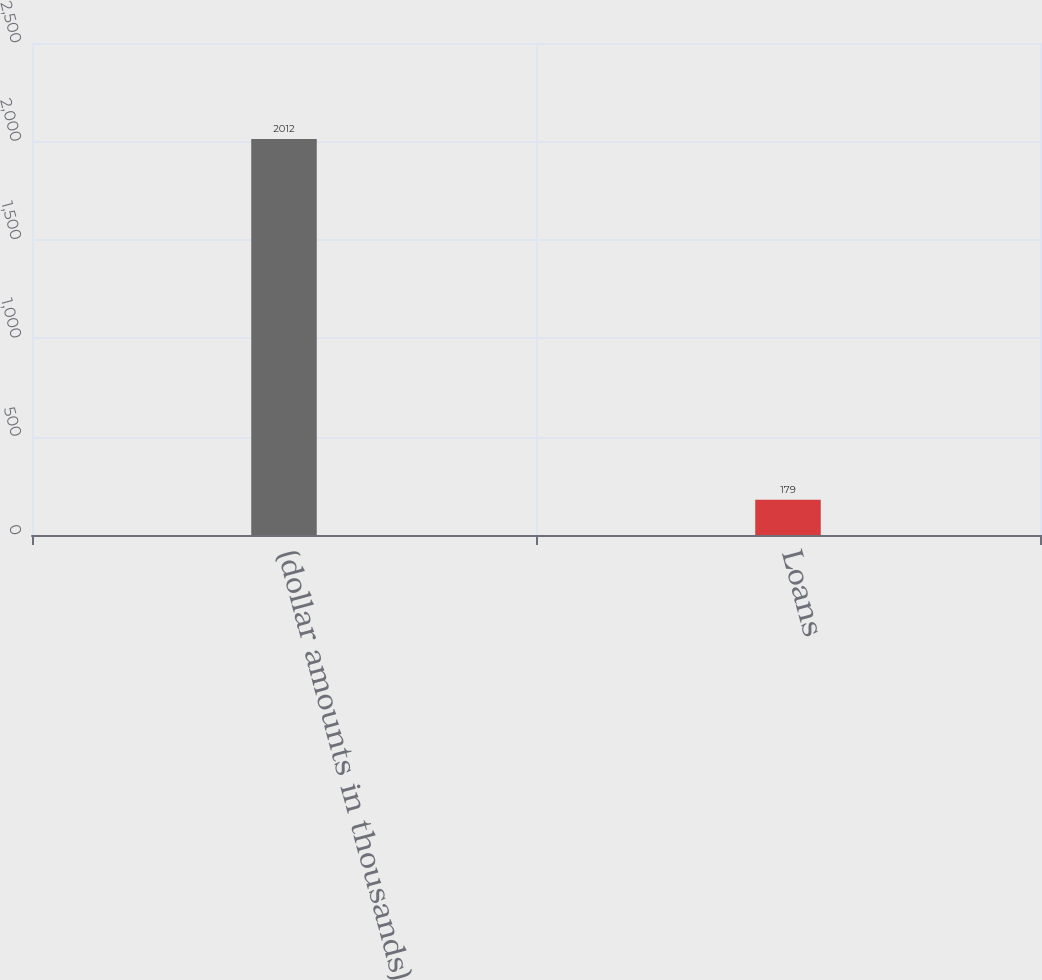<chart> <loc_0><loc_0><loc_500><loc_500><bar_chart><fcel>(dollar amounts in thousands)<fcel>Loans<nl><fcel>2012<fcel>179<nl></chart> 